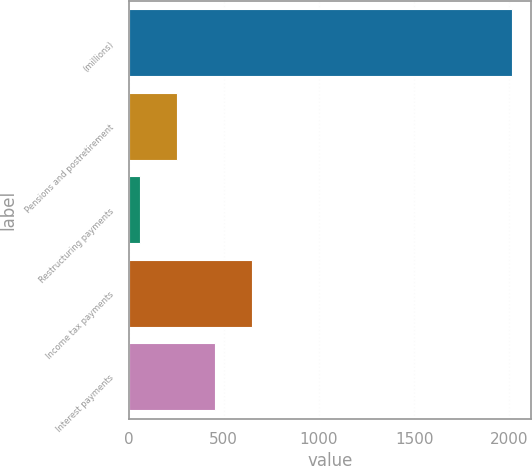Convert chart to OTSL. <chart><loc_0><loc_0><loc_500><loc_500><bar_chart><fcel>(millions)<fcel>Pensions and postretirement<fcel>Restructuring payments<fcel>Income tax payments<fcel>Interest payments<nl><fcel>2015<fcel>257.03<fcel>61.7<fcel>647.69<fcel>452.36<nl></chart> 